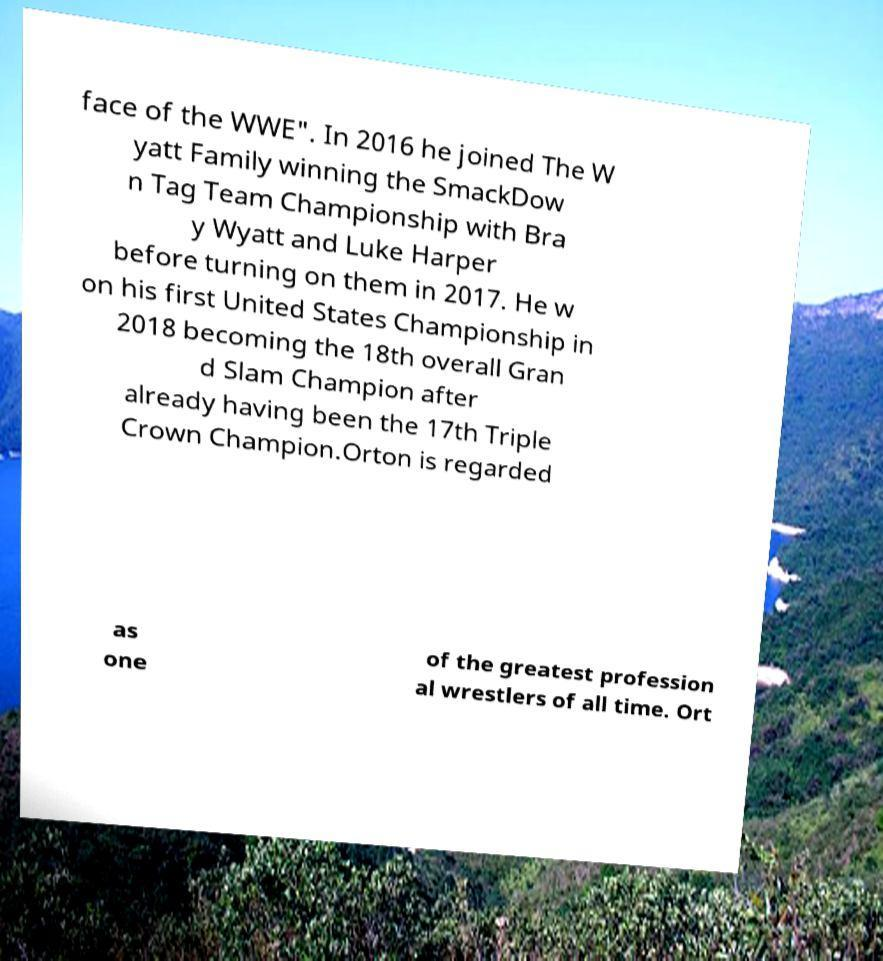There's text embedded in this image that I need extracted. Can you transcribe it verbatim? face of the WWE". In 2016 he joined The W yatt Family winning the SmackDow n Tag Team Championship with Bra y Wyatt and Luke Harper before turning on them in 2017. He w on his first United States Championship in 2018 becoming the 18th overall Gran d Slam Champion after already having been the 17th Triple Crown Champion.Orton is regarded as one of the greatest profession al wrestlers of all time. Ort 